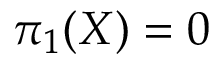<formula> <loc_0><loc_0><loc_500><loc_500>\pi _ { 1 } ( X ) = 0</formula> 